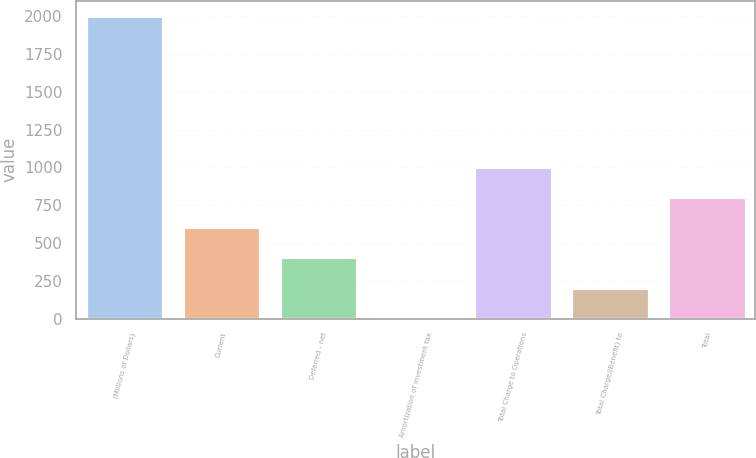Convert chart to OTSL. <chart><loc_0><loc_0><loc_500><loc_500><bar_chart><fcel>(Millions of Dollars)<fcel>Current<fcel>Deferred - net<fcel>Amortization of investment tax<fcel>Total Charge to Operations<fcel>Total Charge/(Benefit) to<fcel>Total<nl><fcel>2004<fcel>605.4<fcel>405.6<fcel>6<fcel>1005<fcel>205.8<fcel>805.2<nl></chart> 